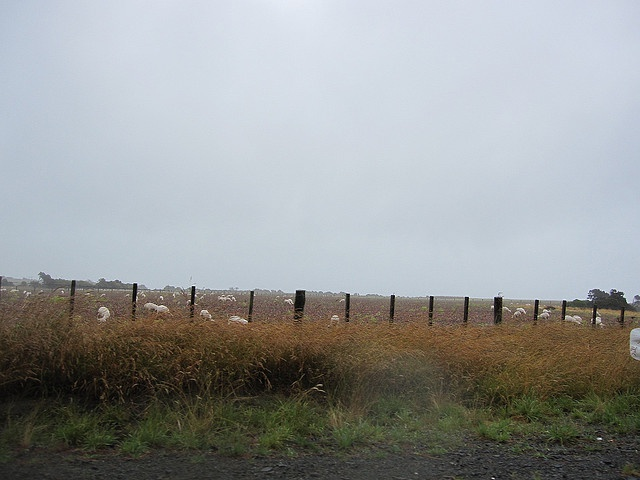Describe the objects in this image and their specific colors. I can see sheep in lightgray, gray, darkgray, and black tones, sheep in lightgray, darkgray, and gray tones, sheep in lightgray, darkgray, and gray tones, sheep in lightgray, darkgray, and gray tones, and sheep in lightgray, darkgray, and gray tones in this image. 